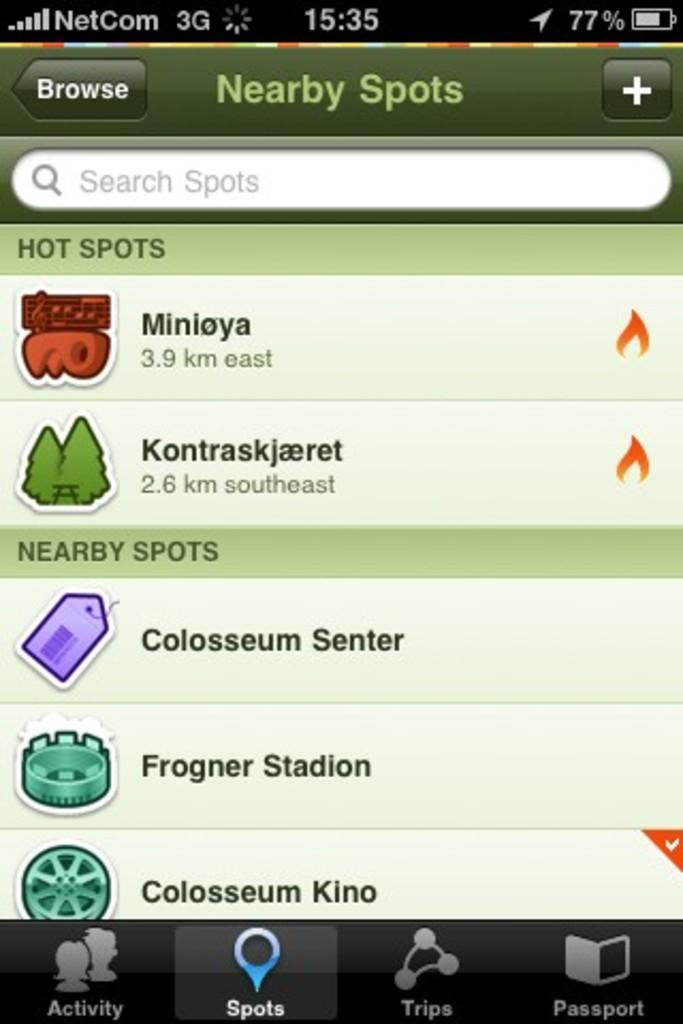Provide a one-sentence caption for the provided image. a page on a phone that says Nearby spots on it. 